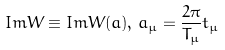<formula> <loc_0><loc_0><loc_500><loc_500>I m W \equiv I m W ( a ) , \, a _ { \mu } = \frac { 2 \pi } { T _ { \mu } } t _ { \mu }</formula> 